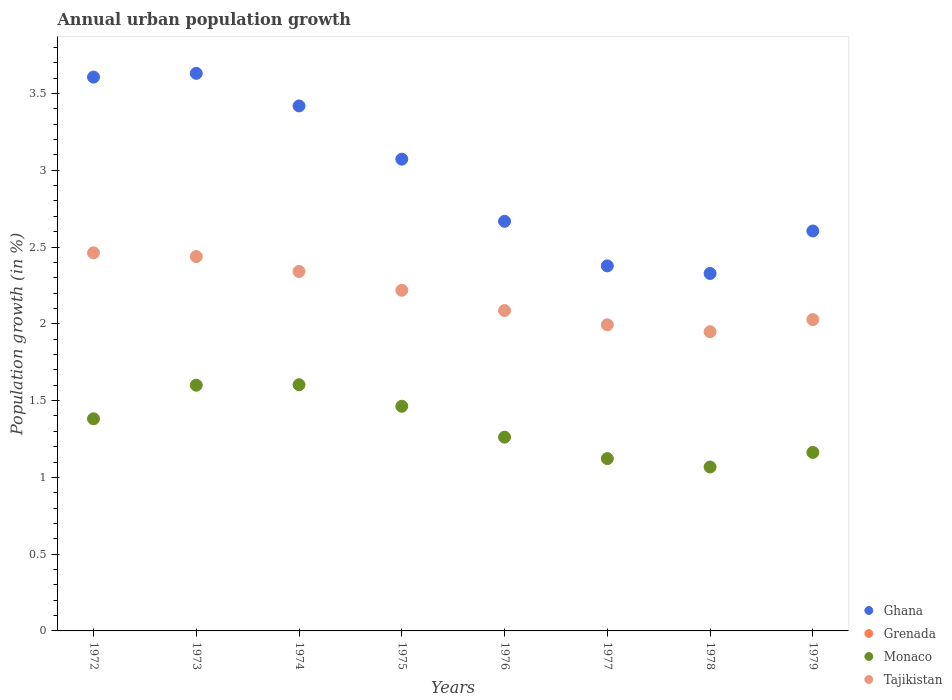Across all years, what is the maximum percentage of urban population growth in Ghana?
Your response must be concise. 3.63. Across all years, what is the minimum percentage of urban population growth in Grenada?
Provide a succinct answer. 0. What is the total percentage of urban population growth in Ghana in the graph?
Offer a very short reply. 23.71. What is the difference between the percentage of urban population growth in Ghana in 1973 and that in 1974?
Ensure brevity in your answer.  0.21. What is the difference between the percentage of urban population growth in Grenada in 1975 and the percentage of urban population growth in Monaco in 1977?
Offer a terse response. -1.12. What is the average percentage of urban population growth in Ghana per year?
Give a very brief answer. 2.96. In the year 1979, what is the difference between the percentage of urban population growth in Monaco and percentage of urban population growth in Tajikistan?
Ensure brevity in your answer.  -0.87. In how many years, is the percentage of urban population growth in Monaco greater than 0.5 %?
Offer a terse response. 8. What is the ratio of the percentage of urban population growth in Ghana in 1972 to that in 1979?
Offer a terse response. 1.38. Is the percentage of urban population growth in Monaco in 1974 less than that in 1975?
Offer a terse response. No. Is the difference between the percentage of urban population growth in Monaco in 1975 and 1976 greater than the difference between the percentage of urban population growth in Tajikistan in 1975 and 1976?
Your answer should be compact. Yes. What is the difference between the highest and the second highest percentage of urban population growth in Tajikistan?
Provide a short and direct response. 0.02. What is the difference between the highest and the lowest percentage of urban population growth in Monaco?
Your answer should be very brief. 0.54. In how many years, is the percentage of urban population growth in Monaco greater than the average percentage of urban population growth in Monaco taken over all years?
Offer a terse response. 4. Is the sum of the percentage of urban population growth in Ghana in 1972 and 1973 greater than the maximum percentage of urban population growth in Tajikistan across all years?
Give a very brief answer. Yes. How many years are there in the graph?
Your answer should be very brief. 8. What is the difference between two consecutive major ticks on the Y-axis?
Offer a very short reply. 0.5. Where does the legend appear in the graph?
Make the answer very short. Bottom right. How are the legend labels stacked?
Make the answer very short. Vertical. What is the title of the graph?
Give a very brief answer. Annual urban population growth. What is the label or title of the X-axis?
Offer a very short reply. Years. What is the label or title of the Y-axis?
Your response must be concise. Population growth (in %). What is the Population growth (in %) of Ghana in 1972?
Ensure brevity in your answer.  3.61. What is the Population growth (in %) in Monaco in 1972?
Offer a terse response. 1.38. What is the Population growth (in %) of Tajikistan in 1972?
Make the answer very short. 2.46. What is the Population growth (in %) in Ghana in 1973?
Offer a terse response. 3.63. What is the Population growth (in %) of Monaco in 1973?
Offer a very short reply. 1.6. What is the Population growth (in %) in Tajikistan in 1973?
Your response must be concise. 2.44. What is the Population growth (in %) in Ghana in 1974?
Your answer should be very brief. 3.42. What is the Population growth (in %) of Grenada in 1974?
Provide a succinct answer. 0. What is the Population growth (in %) of Monaco in 1974?
Offer a very short reply. 1.6. What is the Population growth (in %) of Tajikistan in 1974?
Keep it short and to the point. 2.34. What is the Population growth (in %) in Ghana in 1975?
Provide a succinct answer. 3.07. What is the Population growth (in %) of Monaco in 1975?
Give a very brief answer. 1.46. What is the Population growth (in %) of Tajikistan in 1975?
Your answer should be very brief. 2.22. What is the Population growth (in %) in Ghana in 1976?
Your answer should be compact. 2.67. What is the Population growth (in %) of Grenada in 1976?
Your response must be concise. 0. What is the Population growth (in %) of Monaco in 1976?
Provide a succinct answer. 1.26. What is the Population growth (in %) in Tajikistan in 1976?
Offer a terse response. 2.09. What is the Population growth (in %) in Ghana in 1977?
Your answer should be compact. 2.38. What is the Population growth (in %) of Grenada in 1977?
Provide a short and direct response. 0. What is the Population growth (in %) in Monaco in 1977?
Your answer should be compact. 1.12. What is the Population growth (in %) in Tajikistan in 1977?
Offer a very short reply. 1.99. What is the Population growth (in %) in Ghana in 1978?
Provide a short and direct response. 2.33. What is the Population growth (in %) in Grenada in 1978?
Your answer should be compact. 0. What is the Population growth (in %) of Monaco in 1978?
Keep it short and to the point. 1.07. What is the Population growth (in %) of Tajikistan in 1978?
Provide a succinct answer. 1.95. What is the Population growth (in %) in Ghana in 1979?
Your answer should be compact. 2.6. What is the Population growth (in %) of Grenada in 1979?
Provide a short and direct response. 0. What is the Population growth (in %) in Monaco in 1979?
Your response must be concise. 1.16. What is the Population growth (in %) of Tajikistan in 1979?
Ensure brevity in your answer.  2.03. Across all years, what is the maximum Population growth (in %) of Ghana?
Provide a succinct answer. 3.63. Across all years, what is the maximum Population growth (in %) in Monaco?
Give a very brief answer. 1.6. Across all years, what is the maximum Population growth (in %) of Tajikistan?
Give a very brief answer. 2.46. Across all years, what is the minimum Population growth (in %) of Ghana?
Provide a short and direct response. 2.33. Across all years, what is the minimum Population growth (in %) in Monaco?
Keep it short and to the point. 1.07. Across all years, what is the minimum Population growth (in %) of Tajikistan?
Make the answer very short. 1.95. What is the total Population growth (in %) of Ghana in the graph?
Offer a terse response. 23.71. What is the total Population growth (in %) in Grenada in the graph?
Offer a terse response. 0. What is the total Population growth (in %) of Monaco in the graph?
Your answer should be compact. 10.66. What is the total Population growth (in %) in Tajikistan in the graph?
Your answer should be very brief. 17.52. What is the difference between the Population growth (in %) in Ghana in 1972 and that in 1973?
Provide a succinct answer. -0.02. What is the difference between the Population growth (in %) of Monaco in 1972 and that in 1973?
Keep it short and to the point. -0.22. What is the difference between the Population growth (in %) in Tajikistan in 1972 and that in 1973?
Provide a succinct answer. 0.02. What is the difference between the Population growth (in %) of Ghana in 1972 and that in 1974?
Ensure brevity in your answer.  0.19. What is the difference between the Population growth (in %) in Monaco in 1972 and that in 1974?
Offer a terse response. -0.22. What is the difference between the Population growth (in %) in Tajikistan in 1972 and that in 1974?
Your answer should be very brief. 0.12. What is the difference between the Population growth (in %) of Ghana in 1972 and that in 1975?
Give a very brief answer. 0.53. What is the difference between the Population growth (in %) in Monaco in 1972 and that in 1975?
Your answer should be compact. -0.08. What is the difference between the Population growth (in %) in Tajikistan in 1972 and that in 1975?
Your answer should be compact. 0.24. What is the difference between the Population growth (in %) in Ghana in 1972 and that in 1976?
Provide a succinct answer. 0.94. What is the difference between the Population growth (in %) of Monaco in 1972 and that in 1976?
Offer a very short reply. 0.12. What is the difference between the Population growth (in %) in Tajikistan in 1972 and that in 1976?
Give a very brief answer. 0.38. What is the difference between the Population growth (in %) of Ghana in 1972 and that in 1977?
Your response must be concise. 1.23. What is the difference between the Population growth (in %) in Monaco in 1972 and that in 1977?
Your answer should be very brief. 0.26. What is the difference between the Population growth (in %) of Tajikistan in 1972 and that in 1977?
Your answer should be very brief. 0.47. What is the difference between the Population growth (in %) of Ghana in 1972 and that in 1978?
Provide a short and direct response. 1.28. What is the difference between the Population growth (in %) in Monaco in 1972 and that in 1978?
Make the answer very short. 0.31. What is the difference between the Population growth (in %) in Tajikistan in 1972 and that in 1978?
Provide a succinct answer. 0.51. What is the difference between the Population growth (in %) in Monaco in 1972 and that in 1979?
Provide a succinct answer. 0.22. What is the difference between the Population growth (in %) in Tajikistan in 1972 and that in 1979?
Keep it short and to the point. 0.43. What is the difference between the Population growth (in %) in Ghana in 1973 and that in 1974?
Make the answer very short. 0.21. What is the difference between the Population growth (in %) of Monaco in 1973 and that in 1974?
Offer a terse response. -0. What is the difference between the Population growth (in %) of Tajikistan in 1973 and that in 1974?
Offer a terse response. 0.1. What is the difference between the Population growth (in %) of Ghana in 1973 and that in 1975?
Your answer should be very brief. 0.56. What is the difference between the Population growth (in %) in Monaco in 1973 and that in 1975?
Keep it short and to the point. 0.14. What is the difference between the Population growth (in %) of Tajikistan in 1973 and that in 1975?
Provide a succinct answer. 0.22. What is the difference between the Population growth (in %) of Ghana in 1973 and that in 1976?
Offer a very short reply. 0.96. What is the difference between the Population growth (in %) of Monaco in 1973 and that in 1976?
Provide a succinct answer. 0.34. What is the difference between the Population growth (in %) in Tajikistan in 1973 and that in 1976?
Offer a terse response. 0.35. What is the difference between the Population growth (in %) of Ghana in 1973 and that in 1977?
Give a very brief answer. 1.25. What is the difference between the Population growth (in %) of Monaco in 1973 and that in 1977?
Your answer should be compact. 0.48. What is the difference between the Population growth (in %) of Tajikistan in 1973 and that in 1977?
Keep it short and to the point. 0.44. What is the difference between the Population growth (in %) in Ghana in 1973 and that in 1978?
Your answer should be compact. 1.3. What is the difference between the Population growth (in %) of Monaco in 1973 and that in 1978?
Keep it short and to the point. 0.53. What is the difference between the Population growth (in %) in Tajikistan in 1973 and that in 1978?
Ensure brevity in your answer.  0.49. What is the difference between the Population growth (in %) in Ghana in 1973 and that in 1979?
Make the answer very short. 1.03. What is the difference between the Population growth (in %) in Monaco in 1973 and that in 1979?
Make the answer very short. 0.44. What is the difference between the Population growth (in %) in Tajikistan in 1973 and that in 1979?
Your response must be concise. 0.41. What is the difference between the Population growth (in %) in Ghana in 1974 and that in 1975?
Make the answer very short. 0.35. What is the difference between the Population growth (in %) in Monaco in 1974 and that in 1975?
Your response must be concise. 0.14. What is the difference between the Population growth (in %) of Tajikistan in 1974 and that in 1975?
Ensure brevity in your answer.  0.12. What is the difference between the Population growth (in %) of Ghana in 1974 and that in 1976?
Offer a terse response. 0.75. What is the difference between the Population growth (in %) of Monaco in 1974 and that in 1976?
Provide a short and direct response. 0.34. What is the difference between the Population growth (in %) of Tajikistan in 1974 and that in 1976?
Keep it short and to the point. 0.25. What is the difference between the Population growth (in %) in Ghana in 1974 and that in 1977?
Ensure brevity in your answer.  1.04. What is the difference between the Population growth (in %) of Monaco in 1974 and that in 1977?
Offer a very short reply. 0.48. What is the difference between the Population growth (in %) of Tajikistan in 1974 and that in 1977?
Offer a very short reply. 0.35. What is the difference between the Population growth (in %) in Ghana in 1974 and that in 1978?
Your response must be concise. 1.09. What is the difference between the Population growth (in %) in Monaco in 1974 and that in 1978?
Offer a terse response. 0.54. What is the difference between the Population growth (in %) in Tajikistan in 1974 and that in 1978?
Provide a succinct answer. 0.39. What is the difference between the Population growth (in %) of Ghana in 1974 and that in 1979?
Offer a very short reply. 0.81. What is the difference between the Population growth (in %) of Monaco in 1974 and that in 1979?
Provide a succinct answer. 0.44. What is the difference between the Population growth (in %) of Tajikistan in 1974 and that in 1979?
Your response must be concise. 0.31. What is the difference between the Population growth (in %) in Ghana in 1975 and that in 1976?
Ensure brevity in your answer.  0.4. What is the difference between the Population growth (in %) in Monaco in 1975 and that in 1976?
Your answer should be very brief. 0.2. What is the difference between the Population growth (in %) in Tajikistan in 1975 and that in 1976?
Your answer should be very brief. 0.13. What is the difference between the Population growth (in %) of Ghana in 1975 and that in 1977?
Provide a succinct answer. 0.69. What is the difference between the Population growth (in %) in Monaco in 1975 and that in 1977?
Offer a terse response. 0.34. What is the difference between the Population growth (in %) in Tajikistan in 1975 and that in 1977?
Offer a terse response. 0.22. What is the difference between the Population growth (in %) of Ghana in 1975 and that in 1978?
Give a very brief answer. 0.74. What is the difference between the Population growth (in %) in Monaco in 1975 and that in 1978?
Provide a succinct answer. 0.4. What is the difference between the Population growth (in %) in Tajikistan in 1975 and that in 1978?
Provide a short and direct response. 0.27. What is the difference between the Population growth (in %) of Ghana in 1975 and that in 1979?
Ensure brevity in your answer.  0.47. What is the difference between the Population growth (in %) in Monaco in 1975 and that in 1979?
Provide a short and direct response. 0.3. What is the difference between the Population growth (in %) of Tajikistan in 1975 and that in 1979?
Make the answer very short. 0.19. What is the difference between the Population growth (in %) in Ghana in 1976 and that in 1977?
Your answer should be compact. 0.29. What is the difference between the Population growth (in %) in Monaco in 1976 and that in 1977?
Your response must be concise. 0.14. What is the difference between the Population growth (in %) in Tajikistan in 1976 and that in 1977?
Your answer should be very brief. 0.09. What is the difference between the Population growth (in %) of Ghana in 1976 and that in 1978?
Offer a terse response. 0.34. What is the difference between the Population growth (in %) in Monaco in 1976 and that in 1978?
Your answer should be compact. 0.19. What is the difference between the Population growth (in %) of Tajikistan in 1976 and that in 1978?
Provide a succinct answer. 0.14. What is the difference between the Population growth (in %) in Ghana in 1976 and that in 1979?
Provide a short and direct response. 0.06. What is the difference between the Population growth (in %) in Monaco in 1976 and that in 1979?
Give a very brief answer. 0.1. What is the difference between the Population growth (in %) of Tajikistan in 1976 and that in 1979?
Offer a very short reply. 0.06. What is the difference between the Population growth (in %) in Ghana in 1977 and that in 1978?
Make the answer very short. 0.05. What is the difference between the Population growth (in %) in Monaco in 1977 and that in 1978?
Offer a very short reply. 0.05. What is the difference between the Population growth (in %) of Tajikistan in 1977 and that in 1978?
Offer a very short reply. 0.05. What is the difference between the Population growth (in %) in Ghana in 1977 and that in 1979?
Provide a succinct answer. -0.23. What is the difference between the Population growth (in %) in Monaco in 1977 and that in 1979?
Your answer should be compact. -0.04. What is the difference between the Population growth (in %) in Tajikistan in 1977 and that in 1979?
Your response must be concise. -0.03. What is the difference between the Population growth (in %) in Ghana in 1978 and that in 1979?
Give a very brief answer. -0.28. What is the difference between the Population growth (in %) in Monaco in 1978 and that in 1979?
Your response must be concise. -0.09. What is the difference between the Population growth (in %) in Tajikistan in 1978 and that in 1979?
Give a very brief answer. -0.08. What is the difference between the Population growth (in %) of Ghana in 1972 and the Population growth (in %) of Monaco in 1973?
Your response must be concise. 2.01. What is the difference between the Population growth (in %) in Ghana in 1972 and the Population growth (in %) in Tajikistan in 1973?
Your answer should be very brief. 1.17. What is the difference between the Population growth (in %) of Monaco in 1972 and the Population growth (in %) of Tajikistan in 1973?
Provide a succinct answer. -1.06. What is the difference between the Population growth (in %) in Ghana in 1972 and the Population growth (in %) in Monaco in 1974?
Keep it short and to the point. 2. What is the difference between the Population growth (in %) in Ghana in 1972 and the Population growth (in %) in Tajikistan in 1974?
Ensure brevity in your answer.  1.27. What is the difference between the Population growth (in %) of Monaco in 1972 and the Population growth (in %) of Tajikistan in 1974?
Offer a very short reply. -0.96. What is the difference between the Population growth (in %) in Ghana in 1972 and the Population growth (in %) in Monaco in 1975?
Offer a terse response. 2.14. What is the difference between the Population growth (in %) of Ghana in 1972 and the Population growth (in %) of Tajikistan in 1975?
Provide a short and direct response. 1.39. What is the difference between the Population growth (in %) in Monaco in 1972 and the Population growth (in %) in Tajikistan in 1975?
Give a very brief answer. -0.84. What is the difference between the Population growth (in %) in Ghana in 1972 and the Population growth (in %) in Monaco in 1976?
Offer a terse response. 2.34. What is the difference between the Population growth (in %) of Ghana in 1972 and the Population growth (in %) of Tajikistan in 1976?
Provide a short and direct response. 1.52. What is the difference between the Population growth (in %) of Monaco in 1972 and the Population growth (in %) of Tajikistan in 1976?
Give a very brief answer. -0.7. What is the difference between the Population growth (in %) of Ghana in 1972 and the Population growth (in %) of Monaco in 1977?
Provide a succinct answer. 2.48. What is the difference between the Population growth (in %) in Ghana in 1972 and the Population growth (in %) in Tajikistan in 1977?
Your response must be concise. 1.61. What is the difference between the Population growth (in %) of Monaco in 1972 and the Population growth (in %) of Tajikistan in 1977?
Ensure brevity in your answer.  -0.61. What is the difference between the Population growth (in %) of Ghana in 1972 and the Population growth (in %) of Monaco in 1978?
Offer a terse response. 2.54. What is the difference between the Population growth (in %) of Ghana in 1972 and the Population growth (in %) of Tajikistan in 1978?
Offer a terse response. 1.66. What is the difference between the Population growth (in %) in Monaco in 1972 and the Population growth (in %) in Tajikistan in 1978?
Make the answer very short. -0.57. What is the difference between the Population growth (in %) of Ghana in 1972 and the Population growth (in %) of Monaco in 1979?
Your response must be concise. 2.44. What is the difference between the Population growth (in %) in Ghana in 1972 and the Population growth (in %) in Tajikistan in 1979?
Make the answer very short. 1.58. What is the difference between the Population growth (in %) in Monaco in 1972 and the Population growth (in %) in Tajikistan in 1979?
Keep it short and to the point. -0.65. What is the difference between the Population growth (in %) of Ghana in 1973 and the Population growth (in %) of Monaco in 1974?
Keep it short and to the point. 2.03. What is the difference between the Population growth (in %) of Ghana in 1973 and the Population growth (in %) of Tajikistan in 1974?
Your answer should be compact. 1.29. What is the difference between the Population growth (in %) in Monaco in 1973 and the Population growth (in %) in Tajikistan in 1974?
Your response must be concise. -0.74. What is the difference between the Population growth (in %) of Ghana in 1973 and the Population growth (in %) of Monaco in 1975?
Provide a short and direct response. 2.17. What is the difference between the Population growth (in %) in Ghana in 1973 and the Population growth (in %) in Tajikistan in 1975?
Your answer should be compact. 1.41. What is the difference between the Population growth (in %) of Monaco in 1973 and the Population growth (in %) of Tajikistan in 1975?
Your answer should be compact. -0.62. What is the difference between the Population growth (in %) in Ghana in 1973 and the Population growth (in %) in Monaco in 1976?
Give a very brief answer. 2.37. What is the difference between the Population growth (in %) of Ghana in 1973 and the Population growth (in %) of Tajikistan in 1976?
Offer a terse response. 1.54. What is the difference between the Population growth (in %) of Monaco in 1973 and the Population growth (in %) of Tajikistan in 1976?
Keep it short and to the point. -0.49. What is the difference between the Population growth (in %) in Ghana in 1973 and the Population growth (in %) in Monaco in 1977?
Your response must be concise. 2.51. What is the difference between the Population growth (in %) of Ghana in 1973 and the Population growth (in %) of Tajikistan in 1977?
Your answer should be compact. 1.64. What is the difference between the Population growth (in %) of Monaco in 1973 and the Population growth (in %) of Tajikistan in 1977?
Your answer should be very brief. -0.39. What is the difference between the Population growth (in %) of Ghana in 1973 and the Population growth (in %) of Monaco in 1978?
Provide a succinct answer. 2.56. What is the difference between the Population growth (in %) in Ghana in 1973 and the Population growth (in %) in Tajikistan in 1978?
Your answer should be compact. 1.68. What is the difference between the Population growth (in %) of Monaco in 1973 and the Population growth (in %) of Tajikistan in 1978?
Your response must be concise. -0.35. What is the difference between the Population growth (in %) in Ghana in 1973 and the Population growth (in %) in Monaco in 1979?
Your answer should be compact. 2.47. What is the difference between the Population growth (in %) in Ghana in 1973 and the Population growth (in %) in Tajikistan in 1979?
Give a very brief answer. 1.6. What is the difference between the Population growth (in %) of Monaco in 1973 and the Population growth (in %) of Tajikistan in 1979?
Keep it short and to the point. -0.43. What is the difference between the Population growth (in %) in Ghana in 1974 and the Population growth (in %) in Monaco in 1975?
Offer a terse response. 1.96. What is the difference between the Population growth (in %) of Ghana in 1974 and the Population growth (in %) of Tajikistan in 1975?
Keep it short and to the point. 1.2. What is the difference between the Population growth (in %) of Monaco in 1974 and the Population growth (in %) of Tajikistan in 1975?
Your answer should be very brief. -0.61. What is the difference between the Population growth (in %) of Ghana in 1974 and the Population growth (in %) of Monaco in 1976?
Give a very brief answer. 2.16. What is the difference between the Population growth (in %) in Ghana in 1974 and the Population growth (in %) in Tajikistan in 1976?
Ensure brevity in your answer.  1.33. What is the difference between the Population growth (in %) in Monaco in 1974 and the Population growth (in %) in Tajikistan in 1976?
Your response must be concise. -0.48. What is the difference between the Population growth (in %) of Ghana in 1974 and the Population growth (in %) of Monaco in 1977?
Provide a succinct answer. 2.3. What is the difference between the Population growth (in %) of Ghana in 1974 and the Population growth (in %) of Tajikistan in 1977?
Provide a succinct answer. 1.43. What is the difference between the Population growth (in %) in Monaco in 1974 and the Population growth (in %) in Tajikistan in 1977?
Provide a short and direct response. -0.39. What is the difference between the Population growth (in %) in Ghana in 1974 and the Population growth (in %) in Monaco in 1978?
Your response must be concise. 2.35. What is the difference between the Population growth (in %) in Ghana in 1974 and the Population growth (in %) in Tajikistan in 1978?
Offer a terse response. 1.47. What is the difference between the Population growth (in %) of Monaco in 1974 and the Population growth (in %) of Tajikistan in 1978?
Keep it short and to the point. -0.35. What is the difference between the Population growth (in %) of Ghana in 1974 and the Population growth (in %) of Monaco in 1979?
Your answer should be compact. 2.26. What is the difference between the Population growth (in %) in Ghana in 1974 and the Population growth (in %) in Tajikistan in 1979?
Offer a very short reply. 1.39. What is the difference between the Population growth (in %) of Monaco in 1974 and the Population growth (in %) of Tajikistan in 1979?
Provide a short and direct response. -0.42. What is the difference between the Population growth (in %) of Ghana in 1975 and the Population growth (in %) of Monaco in 1976?
Your response must be concise. 1.81. What is the difference between the Population growth (in %) of Ghana in 1975 and the Population growth (in %) of Tajikistan in 1976?
Ensure brevity in your answer.  0.99. What is the difference between the Population growth (in %) in Monaco in 1975 and the Population growth (in %) in Tajikistan in 1976?
Ensure brevity in your answer.  -0.62. What is the difference between the Population growth (in %) of Ghana in 1975 and the Population growth (in %) of Monaco in 1977?
Your answer should be compact. 1.95. What is the difference between the Population growth (in %) of Ghana in 1975 and the Population growth (in %) of Tajikistan in 1977?
Your answer should be compact. 1.08. What is the difference between the Population growth (in %) of Monaco in 1975 and the Population growth (in %) of Tajikistan in 1977?
Offer a terse response. -0.53. What is the difference between the Population growth (in %) in Ghana in 1975 and the Population growth (in %) in Monaco in 1978?
Offer a very short reply. 2. What is the difference between the Population growth (in %) of Ghana in 1975 and the Population growth (in %) of Tajikistan in 1978?
Ensure brevity in your answer.  1.12. What is the difference between the Population growth (in %) in Monaco in 1975 and the Population growth (in %) in Tajikistan in 1978?
Provide a succinct answer. -0.49. What is the difference between the Population growth (in %) of Ghana in 1975 and the Population growth (in %) of Monaco in 1979?
Make the answer very short. 1.91. What is the difference between the Population growth (in %) in Ghana in 1975 and the Population growth (in %) in Tajikistan in 1979?
Offer a terse response. 1.04. What is the difference between the Population growth (in %) in Monaco in 1975 and the Population growth (in %) in Tajikistan in 1979?
Offer a very short reply. -0.56. What is the difference between the Population growth (in %) of Ghana in 1976 and the Population growth (in %) of Monaco in 1977?
Make the answer very short. 1.55. What is the difference between the Population growth (in %) of Ghana in 1976 and the Population growth (in %) of Tajikistan in 1977?
Ensure brevity in your answer.  0.67. What is the difference between the Population growth (in %) in Monaco in 1976 and the Population growth (in %) in Tajikistan in 1977?
Offer a very short reply. -0.73. What is the difference between the Population growth (in %) in Ghana in 1976 and the Population growth (in %) in Monaco in 1978?
Offer a very short reply. 1.6. What is the difference between the Population growth (in %) of Ghana in 1976 and the Population growth (in %) of Tajikistan in 1978?
Offer a terse response. 0.72. What is the difference between the Population growth (in %) of Monaco in 1976 and the Population growth (in %) of Tajikistan in 1978?
Offer a terse response. -0.69. What is the difference between the Population growth (in %) in Ghana in 1976 and the Population growth (in %) in Monaco in 1979?
Give a very brief answer. 1.51. What is the difference between the Population growth (in %) in Ghana in 1976 and the Population growth (in %) in Tajikistan in 1979?
Your response must be concise. 0.64. What is the difference between the Population growth (in %) in Monaco in 1976 and the Population growth (in %) in Tajikistan in 1979?
Your answer should be compact. -0.77. What is the difference between the Population growth (in %) in Ghana in 1977 and the Population growth (in %) in Monaco in 1978?
Your answer should be very brief. 1.31. What is the difference between the Population growth (in %) in Ghana in 1977 and the Population growth (in %) in Tajikistan in 1978?
Provide a short and direct response. 0.43. What is the difference between the Population growth (in %) in Monaco in 1977 and the Population growth (in %) in Tajikistan in 1978?
Provide a succinct answer. -0.83. What is the difference between the Population growth (in %) in Ghana in 1977 and the Population growth (in %) in Monaco in 1979?
Your response must be concise. 1.21. What is the difference between the Population growth (in %) of Ghana in 1977 and the Population growth (in %) of Tajikistan in 1979?
Offer a very short reply. 0.35. What is the difference between the Population growth (in %) in Monaco in 1977 and the Population growth (in %) in Tajikistan in 1979?
Make the answer very short. -0.91. What is the difference between the Population growth (in %) of Ghana in 1978 and the Population growth (in %) of Monaco in 1979?
Offer a terse response. 1.17. What is the difference between the Population growth (in %) in Ghana in 1978 and the Population growth (in %) in Tajikistan in 1979?
Give a very brief answer. 0.3. What is the difference between the Population growth (in %) in Monaco in 1978 and the Population growth (in %) in Tajikistan in 1979?
Give a very brief answer. -0.96. What is the average Population growth (in %) in Ghana per year?
Make the answer very short. 2.96. What is the average Population growth (in %) of Monaco per year?
Give a very brief answer. 1.33. What is the average Population growth (in %) in Tajikistan per year?
Ensure brevity in your answer.  2.19. In the year 1972, what is the difference between the Population growth (in %) in Ghana and Population growth (in %) in Monaco?
Keep it short and to the point. 2.23. In the year 1972, what is the difference between the Population growth (in %) in Ghana and Population growth (in %) in Tajikistan?
Provide a succinct answer. 1.14. In the year 1972, what is the difference between the Population growth (in %) in Monaco and Population growth (in %) in Tajikistan?
Your response must be concise. -1.08. In the year 1973, what is the difference between the Population growth (in %) of Ghana and Population growth (in %) of Monaco?
Offer a very short reply. 2.03. In the year 1973, what is the difference between the Population growth (in %) of Ghana and Population growth (in %) of Tajikistan?
Provide a succinct answer. 1.19. In the year 1973, what is the difference between the Population growth (in %) of Monaco and Population growth (in %) of Tajikistan?
Your answer should be very brief. -0.84. In the year 1974, what is the difference between the Population growth (in %) in Ghana and Population growth (in %) in Monaco?
Make the answer very short. 1.82. In the year 1974, what is the difference between the Population growth (in %) in Ghana and Population growth (in %) in Tajikistan?
Ensure brevity in your answer.  1.08. In the year 1974, what is the difference between the Population growth (in %) of Monaco and Population growth (in %) of Tajikistan?
Offer a terse response. -0.74. In the year 1975, what is the difference between the Population growth (in %) of Ghana and Population growth (in %) of Monaco?
Make the answer very short. 1.61. In the year 1975, what is the difference between the Population growth (in %) in Ghana and Population growth (in %) in Tajikistan?
Make the answer very short. 0.85. In the year 1975, what is the difference between the Population growth (in %) in Monaco and Population growth (in %) in Tajikistan?
Make the answer very short. -0.76. In the year 1976, what is the difference between the Population growth (in %) in Ghana and Population growth (in %) in Monaco?
Offer a terse response. 1.41. In the year 1976, what is the difference between the Population growth (in %) in Ghana and Population growth (in %) in Tajikistan?
Give a very brief answer. 0.58. In the year 1976, what is the difference between the Population growth (in %) of Monaco and Population growth (in %) of Tajikistan?
Offer a terse response. -0.82. In the year 1977, what is the difference between the Population growth (in %) of Ghana and Population growth (in %) of Monaco?
Ensure brevity in your answer.  1.26. In the year 1977, what is the difference between the Population growth (in %) in Ghana and Population growth (in %) in Tajikistan?
Your answer should be compact. 0.38. In the year 1977, what is the difference between the Population growth (in %) of Monaco and Population growth (in %) of Tajikistan?
Keep it short and to the point. -0.87. In the year 1978, what is the difference between the Population growth (in %) in Ghana and Population growth (in %) in Monaco?
Offer a very short reply. 1.26. In the year 1978, what is the difference between the Population growth (in %) in Ghana and Population growth (in %) in Tajikistan?
Make the answer very short. 0.38. In the year 1978, what is the difference between the Population growth (in %) in Monaco and Population growth (in %) in Tajikistan?
Your answer should be compact. -0.88. In the year 1979, what is the difference between the Population growth (in %) in Ghana and Population growth (in %) in Monaco?
Your answer should be very brief. 1.44. In the year 1979, what is the difference between the Population growth (in %) in Ghana and Population growth (in %) in Tajikistan?
Give a very brief answer. 0.58. In the year 1979, what is the difference between the Population growth (in %) of Monaco and Population growth (in %) of Tajikistan?
Provide a short and direct response. -0.86. What is the ratio of the Population growth (in %) of Monaco in 1972 to that in 1973?
Offer a terse response. 0.86. What is the ratio of the Population growth (in %) of Tajikistan in 1972 to that in 1973?
Ensure brevity in your answer.  1.01. What is the ratio of the Population growth (in %) of Ghana in 1972 to that in 1974?
Provide a short and direct response. 1.05. What is the ratio of the Population growth (in %) in Monaco in 1972 to that in 1974?
Offer a terse response. 0.86. What is the ratio of the Population growth (in %) of Tajikistan in 1972 to that in 1974?
Offer a terse response. 1.05. What is the ratio of the Population growth (in %) of Ghana in 1972 to that in 1975?
Make the answer very short. 1.17. What is the ratio of the Population growth (in %) in Monaco in 1972 to that in 1975?
Provide a succinct answer. 0.94. What is the ratio of the Population growth (in %) in Tajikistan in 1972 to that in 1975?
Offer a terse response. 1.11. What is the ratio of the Population growth (in %) in Ghana in 1972 to that in 1976?
Provide a succinct answer. 1.35. What is the ratio of the Population growth (in %) of Monaco in 1972 to that in 1976?
Your response must be concise. 1.09. What is the ratio of the Population growth (in %) of Tajikistan in 1972 to that in 1976?
Keep it short and to the point. 1.18. What is the ratio of the Population growth (in %) of Ghana in 1972 to that in 1977?
Your answer should be very brief. 1.52. What is the ratio of the Population growth (in %) of Monaco in 1972 to that in 1977?
Keep it short and to the point. 1.23. What is the ratio of the Population growth (in %) of Tajikistan in 1972 to that in 1977?
Ensure brevity in your answer.  1.24. What is the ratio of the Population growth (in %) in Ghana in 1972 to that in 1978?
Provide a short and direct response. 1.55. What is the ratio of the Population growth (in %) in Monaco in 1972 to that in 1978?
Keep it short and to the point. 1.29. What is the ratio of the Population growth (in %) of Tajikistan in 1972 to that in 1978?
Offer a terse response. 1.26. What is the ratio of the Population growth (in %) in Ghana in 1972 to that in 1979?
Make the answer very short. 1.38. What is the ratio of the Population growth (in %) in Monaco in 1972 to that in 1979?
Offer a very short reply. 1.19. What is the ratio of the Population growth (in %) in Tajikistan in 1972 to that in 1979?
Provide a short and direct response. 1.21. What is the ratio of the Population growth (in %) in Ghana in 1973 to that in 1974?
Give a very brief answer. 1.06. What is the ratio of the Population growth (in %) in Tajikistan in 1973 to that in 1974?
Make the answer very short. 1.04. What is the ratio of the Population growth (in %) in Ghana in 1973 to that in 1975?
Provide a succinct answer. 1.18. What is the ratio of the Population growth (in %) of Monaco in 1973 to that in 1975?
Give a very brief answer. 1.09. What is the ratio of the Population growth (in %) in Tajikistan in 1973 to that in 1975?
Offer a very short reply. 1.1. What is the ratio of the Population growth (in %) in Ghana in 1973 to that in 1976?
Make the answer very short. 1.36. What is the ratio of the Population growth (in %) of Monaco in 1973 to that in 1976?
Offer a terse response. 1.27. What is the ratio of the Population growth (in %) of Tajikistan in 1973 to that in 1976?
Provide a succinct answer. 1.17. What is the ratio of the Population growth (in %) in Ghana in 1973 to that in 1977?
Provide a short and direct response. 1.53. What is the ratio of the Population growth (in %) in Monaco in 1973 to that in 1977?
Offer a very short reply. 1.43. What is the ratio of the Population growth (in %) in Tajikistan in 1973 to that in 1977?
Keep it short and to the point. 1.22. What is the ratio of the Population growth (in %) of Ghana in 1973 to that in 1978?
Your answer should be compact. 1.56. What is the ratio of the Population growth (in %) of Monaco in 1973 to that in 1978?
Your answer should be very brief. 1.5. What is the ratio of the Population growth (in %) in Tajikistan in 1973 to that in 1978?
Offer a terse response. 1.25. What is the ratio of the Population growth (in %) in Ghana in 1973 to that in 1979?
Provide a short and direct response. 1.39. What is the ratio of the Population growth (in %) in Monaco in 1973 to that in 1979?
Ensure brevity in your answer.  1.38. What is the ratio of the Population growth (in %) in Tajikistan in 1973 to that in 1979?
Offer a very short reply. 1.2. What is the ratio of the Population growth (in %) in Ghana in 1974 to that in 1975?
Your answer should be compact. 1.11. What is the ratio of the Population growth (in %) in Monaco in 1974 to that in 1975?
Offer a terse response. 1.1. What is the ratio of the Population growth (in %) in Tajikistan in 1974 to that in 1975?
Provide a succinct answer. 1.06. What is the ratio of the Population growth (in %) in Ghana in 1974 to that in 1976?
Keep it short and to the point. 1.28. What is the ratio of the Population growth (in %) of Monaco in 1974 to that in 1976?
Your answer should be compact. 1.27. What is the ratio of the Population growth (in %) in Tajikistan in 1974 to that in 1976?
Ensure brevity in your answer.  1.12. What is the ratio of the Population growth (in %) of Ghana in 1974 to that in 1977?
Offer a very short reply. 1.44. What is the ratio of the Population growth (in %) of Monaco in 1974 to that in 1977?
Provide a short and direct response. 1.43. What is the ratio of the Population growth (in %) of Tajikistan in 1974 to that in 1977?
Make the answer very short. 1.17. What is the ratio of the Population growth (in %) in Ghana in 1974 to that in 1978?
Offer a very short reply. 1.47. What is the ratio of the Population growth (in %) of Monaco in 1974 to that in 1978?
Provide a succinct answer. 1.5. What is the ratio of the Population growth (in %) in Tajikistan in 1974 to that in 1978?
Provide a short and direct response. 1.2. What is the ratio of the Population growth (in %) in Ghana in 1974 to that in 1979?
Provide a short and direct response. 1.31. What is the ratio of the Population growth (in %) in Monaco in 1974 to that in 1979?
Your response must be concise. 1.38. What is the ratio of the Population growth (in %) of Tajikistan in 1974 to that in 1979?
Provide a short and direct response. 1.15. What is the ratio of the Population growth (in %) in Ghana in 1975 to that in 1976?
Your response must be concise. 1.15. What is the ratio of the Population growth (in %) of Monaco in 1975 to that in 1976?
Your answer should be compact. 1.16. What is the ratio of the Population growth (in %) in Tajikistan in 1975 to that in 1976?
Give a very brief answer. 1.06. What is the ratio of the Population growth (in %) in Ghana in 1975 to that in 1977?
Your answer should be compact. 1.29. What is the ratio of the Population growth (in %) in Monaco in 1975 to that in 1977?
Offer a terse response. 1.3. What is the ratio of the Population growth (in %) of Tajikistan in 1975 to that in 1977?
Give a very brief answer. 1.11. What is the ratio of the Population growth (in %) of Ghana in 1975 to that in 1978?
Make the answer very short. 1.32. What is the ratio of the Population growth (in %) in Monaco in 1975 to that in 1978?
Make the answer very short. 1.37. What is the ratio of the Population growth (in %) of Tajikistan in 1975 to that in 1978?
Keep it short and to the point. 1.14. What is the ratio of the Population growth (in %) of Ghana in 1975 to that in 1979?
Ensure brevity in your answer.  1.18. What is the ratio of the Population growth (in %) of Monaco in 1975 to that in 1979?
Your answer should be compact. 1.26. What is the ratio of the Population growth (in %) of Tajikistan in 1975 to that in 1979?
Your answer should be compact. 1.09. What is the ratio of the Population growth (in %) of Ghana in 1976 to that in 1977?
Make the answer very short. 1.12. What is the ratio of the Population growth (in %) of Monaco in 1976 to that in 1977?
Provide a short and direct response. 1.12. What is the ratio of the Population growth (in %) in Tajikistan in 1976 to that in 1977?
Provide a succinct answer. 1.05. What is the ratio of the Population growth (in %) in Ghana in 1976 to that in 1978?
Your response must be concise. 1.15. What is the ratio of the Population growth (in %) in Monaco in 1976 to that in 1978?
Your response must be concise. 1.18. What is the ratio of the Population growth (in %) in Tajikistan in 1976 to that in 1978?
Offer a terse response. 1.07. What is the ratio of the Population growth (in %) in Ghana in 1976 to that in 1979?
Provide a succinct answer. 1.02. What is the ratio of the Population growth (in %) of Monaco in 1976 to that in 1979?
Ensure brevity in your answer.  1.09. What is the ratio of the Population growth (in %) of Ghana in 1977 to that in 1978?
Offer a terse response. 1.02. What is the ratio of the Population growth (in %) of Monaco in 1977 to that in 1978?
Provide a short and direct response. 1.05. What is the ratio of the Population growth (in %) in Tajikistan in 1977 to that in 1978?
Provide a short and direct response. 1.02. What is the ratio of the Population growth (in %) of Ghana in 1977 to that in 1979?
Offer a terse response. 0.91. What is the ratio of the Population growth (in %) of Monaco in 1977 to that in 1979?
Offer a very short reply. 0.97. What is the ratio of the Population growth (in %) of Tajikistan in 1977 to that in 1979?
Make the answer very short. 0.98. What is the ratio of the Population growth (in %) in Ghana in 1978 to that in 1979?
Provide a short and direct response. 0.89. What is the ratio of the Population growth (in %) in Monaco in 1978 to that in 1979?
Make the answer very short. 0.92. What is the ratio of the Population growth (in %) in Tajikistan in 1978 to that in 1979?
Your response must be concise. 0.96. What is the difference between the highest and the second highest Population growth (in %) of Ghana?
Provide a short and direct response. 0.02. What is the difference between the highest and the second highest Population growth (in %) in Monaco?
Your answer should be compact. 0. What is the difference between the highest and the second highest Population growth (in %) in Tajikistan?
Make the answer very short. 0.02. What is the difference between the highest and the lowest Population growth (in %) in Ghana?
Make the answer very short. 1.3. What is the difference between the highest and the lowest Population growth (in %) of Monaco?
Your answer should be very brief. 0.54. What is the difference between the highest and the lowest Population growth (in %) in Tajikistan?
Ensure brevity in your answer.  0.51. 